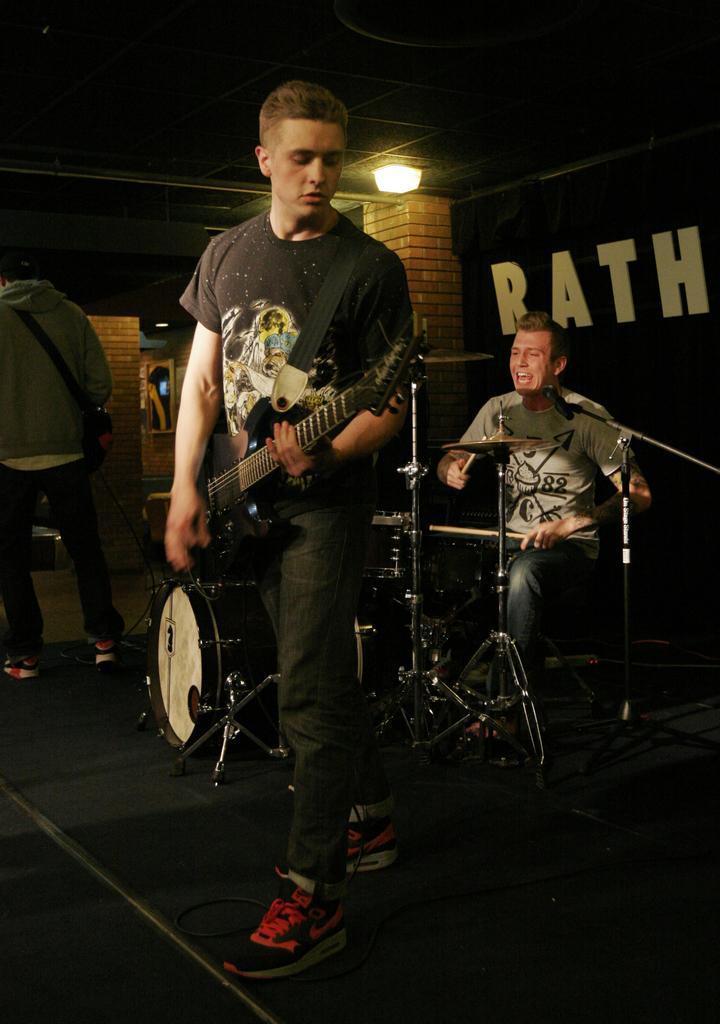Please provide a concise description of this image. In this image i can see a man holding a guitar and playing at the back ground there is another man sitting and playing musical instrument, a wall and at the top there is a light. 